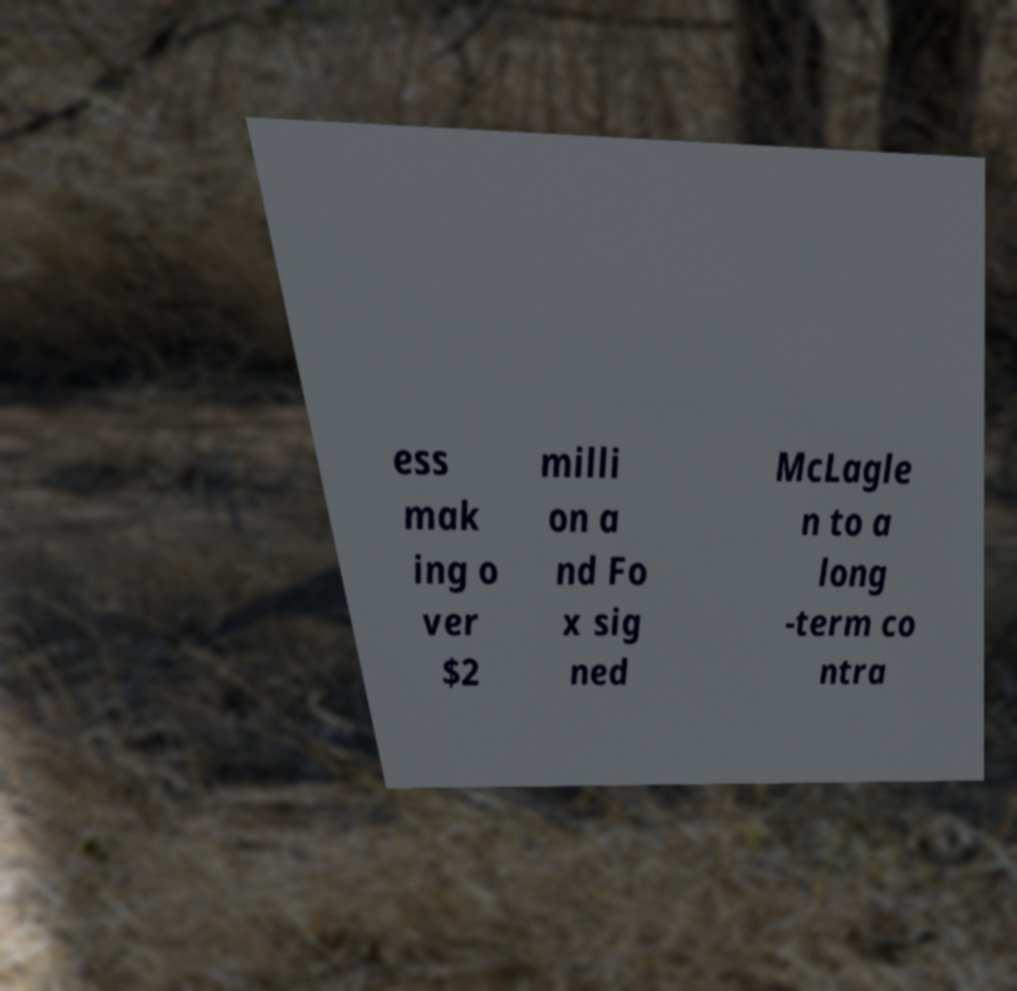Can you read and provide the text displayed in the image?This photo seems to have some interesting text. Can you extract and type it out for me? ess mak ing o ver $2 milli on a nd Fo x sig ned McLagle n to a long -term co ntra 